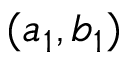Convert formula to latex. <formula><loc_0><loc_0><loc_500><loc_500>( a _ { 1 } , b _ { 1 } )</formula> 